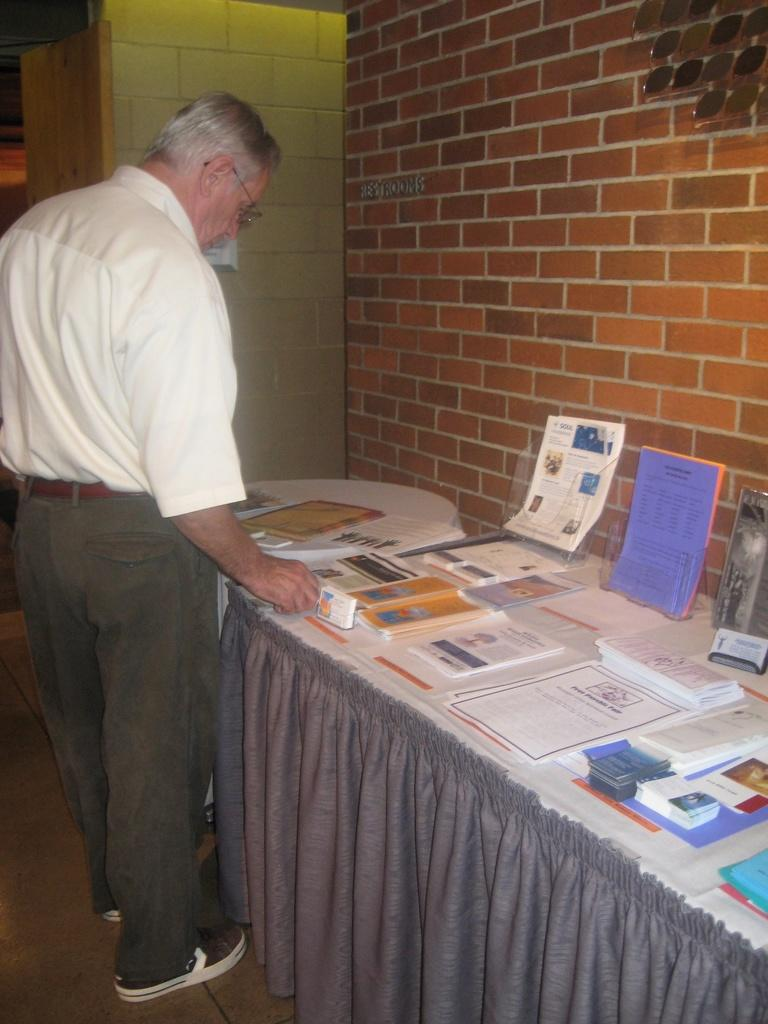What is the person in the image doing? The person is standing in front of a table. What objects can be seen on the table? There are books placed on the table. What is visible in the background of the image? There is a wall in the background of the image. Can you hear the bell ringing in the image? There is no bell present in the image, so it cannot be heard. 